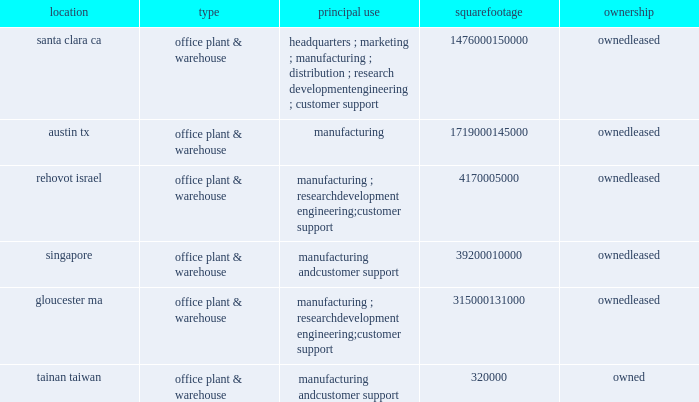Item 2 : properties information concerning applied 2019s principal properties at october 27 , 2013 is set forth below : location type principal use square footage ownership santa clara , ca .
Office , plant & warehouse headquarters ; marketing ; manufacturing ; distribution ; research , development , engineering ; customer support 1476000 150000 leased austin , tx .
Office , plant & warehouse manufacturing 1719000 145000 leased rehovot , israel .
Office , plant & warehouse manufacturing ; research , development , engineering ; customer support 417000 leased singapore .
Office , plant & warehouse manufacturing and customer support 392000 10000 leased gloucester , ma .
Office , plant & warehouse manufacturing ; research , development , engineering ; customer support 315000 131000 leased tainan , taiwan .
Office , plant & warehouse manufacturing and customer support 320000 owned because of the interrelation of applied 2019s operations , properties within a country may be shared by the segments operating within that country .
Products in the silicon systems group are manufactured in austin , texas ; singapore ; gloucester , massachusetts ; and rehovot , israel .
Remanufactured equipment products in the applied global services segment are produced primarily in austin , texas .
Products in the display segment are manufactured in tainan , taiwan ; santa clara , california ; and alzenau , germany .
Products in the energy and environmental solutions segment are primarily manufactured in alzenau , germany ; treviso , italy ; and cheseaux , switzerland .
In addition to the above properties , applied also owns and leases offices , plants and/or warehouse locations in 78 locations throughout the world : 18 in europe , 21 in japan , 15 in north america ( principally the united states ) , 8 in china , 7 in korea , 6 in southeast asia , and 3 in taiwan .
These facilities are principally used for manufacturing ; research , development and engineering ; and marketing , sales and/or customer support .
Applied also owns a total of approximately 139 acres of buildable land in texas , california , israel and italy that could accommodate additional building space .
Applied considers the properties that it owns or leases as adequate to meet its current and future requirements .
Applied regularly assesses the size , capability and location of its global infrastructure and periodically makes adjustments based on these assessments. .
Item 2 : properties information concerning applied 2019s principal properties at october 27 , 2013 is set forth below : location type principal use square footage ownership santa clara , ca .
Office , plant & warehouse headquarters ; marketing ; manufacturing ; distribution ; research , development , engineering ; customer support 1476000 150000 leased austin , tx .
Office , plant & warehouse manufacturing 1719000 145000 leased rehovot , israel .
Office , plant & warehouse manufacturing ; research , development , engineering ; customer support 417000 leased singapore .
Office , plant & warehouse manufacturing and customer support 392000 10000 leased gloucester , ma .
Office , plant & warehouse manufacturing ; research , development , engineering ; customer support 315000 131000 leased tainan , taiwan .
Office , plant & warehouse manufacturing and customer support 320000 owned because of the interrelation of applied 2019s operations , properties within a country may be shared by the segments operating within that country .
Products in the silicon systems group are manufactured in austin , texas ; singapore ; gloucester , massachusetts ; and rehovot , israel .
Remanufactured equipment products in the applied global services segment are produced primarily in austin , texas .
Products in the display segment are manufactured in tainan , taiwan ; santa clara , california ; and alzenau , germany .
Products in the energy and environmental solutions segment are primarily manufactured in alzenau , germany ; treviso , italy ; and cheseaux , switzerland .
In addition to the above properties , applied also owns and leases offices , plants and/or warehouse locations in 78 locations throughout the world : 18 in europe , 21 in japan , 15 in north america ( principally the united states ) , 8 in china , 7 in korea , 6 in southeast asia , and 3 in taiwan .
These facilities are principally used for manufacturing ; research , development and engineering ; and marketing , sales and/or customer support .
Applied also owns a total of approximately 139 acres of buildable land in texas , california , israel and italy that could accommodate additional building space .
Applied considers the properties that it owns or leases as adequate to meet its current and future requirements .
Applied regularly assesses the size , capability and location of its global infrastructure and periodically makes adjustments based on these assessments. .
What percent of warehouse locations are located in japan .? 
Rationale: to find the percentage one must divide the warehouse locations in japan by the total warehouse locations .
Computations: (21 / 78)
Answer: 0.26923. 